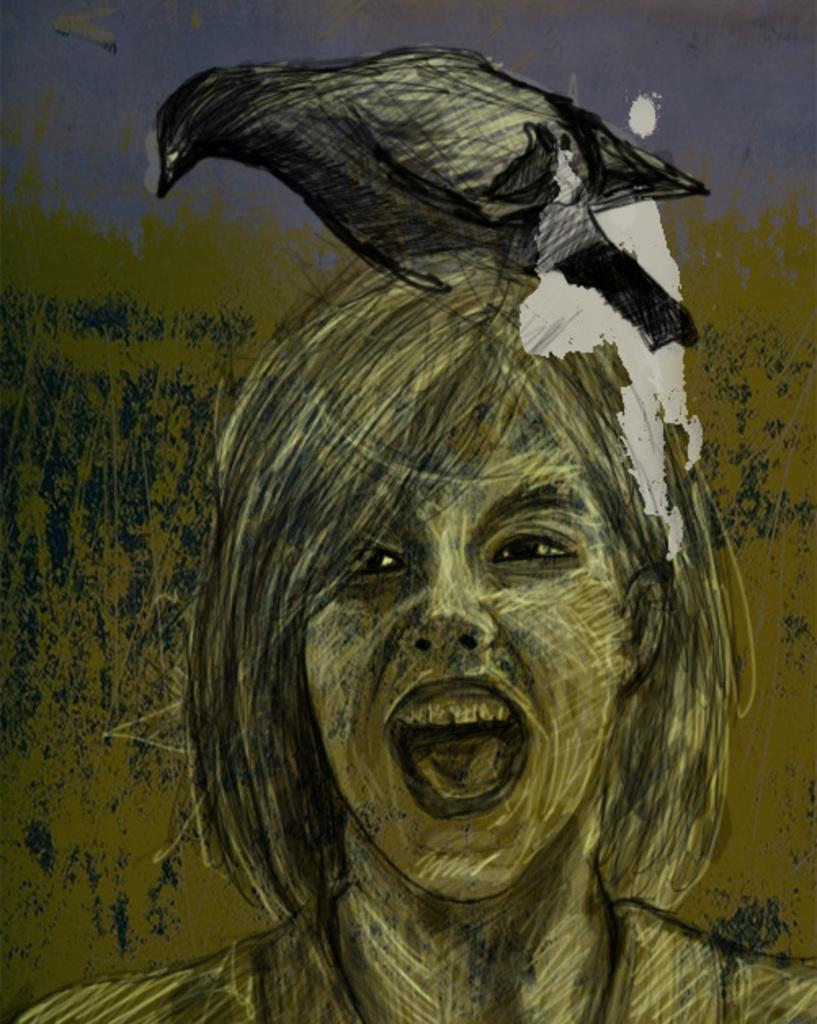What is depicted in the painting in the image? There is a painting of a girl in the image. What animal can be seen in the image? There is a black color crow in the image. What part of the natural environment is visible in the image? The sky is visible in the image. What type of fireman is shown in the image? There is no fireman present in the image. What limit is being tested in the image? There is no indication of a limit being tested in the image. 